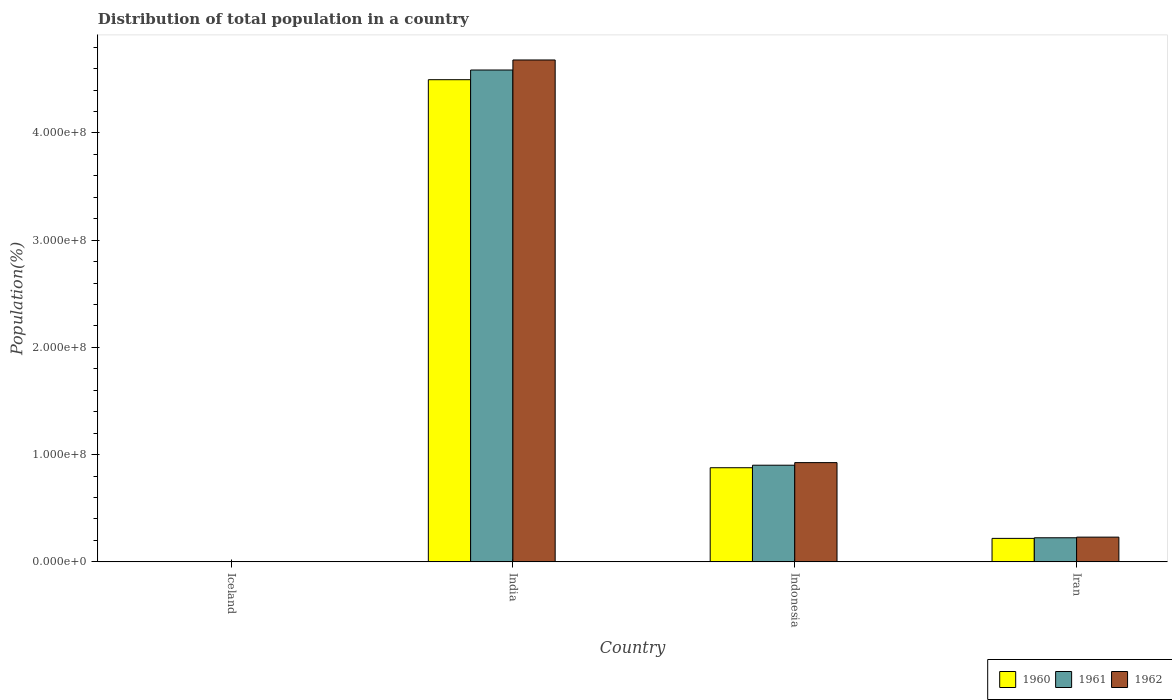Are the number of bars per tick equal to the number of legend labels?
Provide a succinct answer. Yes. What is the label of the 1st group of bars from the left?
Give a very brief answer. Iceland. What is the population of in 1960 in Iran?
Offer a terse response. 2.19e+07. Across all countries, what is the maximum population of in 1960?
Provide a short and direct response. 4.50e+08. Across all countries, what is the minimum population of in 1961?
Give a very brief answer. 1.79e+05. In which country was the population of in 1962 maximum?
Your answer should be very brief. India. What is the total population of in 1960 in the graph?
Provide a succinct answer. 5.60e+08. What is the difference between the population of in 1961 in Indonesia and that in Iran?
Keep it short and to the point. 6.77e+07. What is the difference between the population of in 1960 in Iran and the population of in 1961 in Iceland?
Offer a terse response. 2.17e+07. What is the average population of in 1961 per country?
Provide a short and direct response. 1.43e+08. What is the difference between the population of of/in 1962 and population of of/in 1961 in India?
Your response must be concise. 9.36e+06. In how many countries, is the population of in 1962 greater than 420000000 %?
Your response must be concise. 1. What is the ratio of the population of in 1961 in India to that in Indonesia?
Give a very brief answer. 5.09. Is the population of in 1962 in Iceland less than that in Indonesia?
Give a very brief answer. Yes. Is the difference between the population of in 1962 in Indonesia and Iran greater than the difference between the population of in 1961 in Indonesia and Iran?
Ensure brevity in your answer.  Yes. What is the difference between the highest and the second highest population of in 1961?
Make the answer very short. 3.69e+08. What is the difference between the highest and the lowest population of in 1960?
Provide a short and direct response. 4.49e+08. In how many countries, is the population of in 1961 greater than the average population of in 1961 taken over all countries?
Ensure brevity in your answer.  1. Is the sum of the population of in 1960 in Iceland and India greater than the maximum population of in 1961 across all countries?
Offer a terse response. No. What does the 3rd bar from the right in Indonesia represents?
Offer a terse response. 1960. How many bars are there?
Your response must be concise. 12. Are the values on the major ticks of Y-axis written in scientific E-notation?
Offer a terse response. Yes. Does the graph contain any zero values?
Provide a short and direct response. No. Where does the legend appear in the graph?
Your response must be concise. Bottom right. What is the title of the graph?
Provide a succinct answer. Distribution of total population in a country. What is the label or title of the X-axis?
Your answer should be very brief. Country. What is the label or title of the Y-axis?
Make the answer very short. Population(%). What is the Population(%) of 1960 in Iceland?
Give a very brief answer. 1.76e+05. What is the Population(%) in 1961 in Iceland?
Make the answer very short. 1.79e+05. What is the Population(%) in 1962 in Iceland?
Give a very brief answer. 1.82e+05. What is the Population(%) in 1960 in India?
Provide a succinct answer. 4.50e+08. What is the Population(%) of 1961 in India?
Offer a terse response. 4.59e+08. What is the Population(%) of 1962 in India?
Offer a very short reply. 4.68e+08. What is the Population(%) of 1960 in Indonesia?
Ensure brevity in your answer.  8.78e+07. What is the Population(%) of 1961 in Indonesia?
Provide a succinct answer. 9.01e+07. What is the Population(%) of 1962 in Indonesia?
Your answer should be very brief. 9.26e+07. What is the Population(%) of 1960 in Iran?
Give a very brief answer. 2.19e+07. What is the Population(%) of 1961 in Iran?
Your answer should be very brief. 2.25e+07. What is the Population(%) of 1962 in Iran?
Make the answer very short. 2.31e+07. Across all countries, what is the maximum Population(%) of 1960?
Make the answer very short. 4.50e+08. Across all countries, what is the maximum Population(%) in 1961?
Keep it short and to the point. 4.59e+08. Across all countries, what is the maximum Population(%) of 1962?
Offer a terse response. 4.68e+08. Across all countries, what is the minimum Population(%) in 1960?
Your answer should be compact. 1.76e+05. Across all countries, what is the minimum Population(%) in 1961?
Give a very brief answer. 1.79e+05. Across all countries, what is the minimum Population(%) in 1962?
Make the answer very short. 1.82e+05. What is the total Population(%) in 1960 in the graph?
Offer a terse response. 5.60e+08. What is the total Population(%) in 1961 in the graph?
Your answer should be compact. 5.71e+08. What is the total Population(%) in 1962 in the graph?
Provide a succinct answer. 5.84e+08. What is the difference between the Population(%) in 1960 in Iceland and that in India?
Your response must be concise. -4.49e+08. What is the difference between the Population(%) in 1961 in Iceland and that in India?
Give a very brief answer. -4.59e+08. What is the difference between the Population(%) in 1962 in Iceland and that in India?
Provide a short and direct response. -4.68e+08. What is the difference between the Population(%) in 1960 in Iceland and that in Indonesia?
Ensure brevity in your answer.  -8.76e+07. What is the difference between the Population(%) in 1961 in Iceland and that in Indonesia?
Ensure brevity in your answer.  -9.00e+07. What is the difference between the Population(%) in 1962 in Iceland and that in Indonesia?
Provide a short and direct response. -9.24e+07. What is the difference between the Population(%) of 1960 in Iceland and that in Iran?
Your answer should be compact. -2.17e+07. What is the difference between the Population(%) in 1961 in Iceland and that in Iran?
Keep it short and to the point. -2.23e+07. What is the difference between the Population(%) of 1962 in Iceland and that in Iran?
Provide a short and direct response. -2.29e+07. What is the difference between the Population(%) of 1960 in India and that in Indonesia?
Give a very brief answer. 3.62e+08. What is the difference between the Population(%) of 1961 in India and that in Indonesia?
Ensure brevity in your answer.  3.69e+08. What is the difference between the Population(%) of 1962 in India and that in Indonesia?
Keep it short and to the point. 3.75e+08. What is the difference between the Population(%) of 1960 in India and that in Iran?
Offer a very short reply. 4.28e+08. What is the difference between the Population(%) of 1961 in India and that in Iran?
Your answer should be compact. 4.36e+08. What is the difference between the Population(%) in 1962 in India and that in Iran?
Your answer should be very brief. 4.45e+08. What is the difference between the Population(%) of 1960 in Indonesia and that in Iran?
Give a very brief answer. 6.59e+07. What is the difference between the Population(%) of 1961 in Indonesia and that in Iran?
Provide a succinct answer. 6.77e+07. What is the difference between the Population(%) of 1962 in Indonesia and that in Iran?
Keep it short and to the point. 6.95e+07. What is the difference between the Population(%) of 1960 in Iceland and the Population(%) of 1961 in India?
Your response must be concise. -4.59e+08. What is the difference between the Population(%) of 1960 in Iceland and the Population(%) of 1962 in India?
Keep it short and to the point. -4.68e+08. What is the difference between the Population(%) in 1961 in Iceland and the Population(%) in 1962 in India?
Give a very brief answer. -4.68e+08. What is the difference between the Population(%) in 1960 in Iceland and the Population(%) in 1961 in Indonesia?
Offer a terse response. -9.00e+07. What is the difference between the Population(%) of 1960 in Iceland and the Population(%) of 1962 in Indonesia?
Provide a short and direct response. -9.24e+07. What is the difference between the Population(%) in 1961 in Iceland and the Population(%) in 1962 in Indonesia?
Your response must be concise. -9.24e+07. What is the difference between the Population(%) of 1960 in Iceland and the Population(%) of 1961 in Iran?
Make the answer very short. -2.23e+07. What is the difference between the Population(%) of 1960 in Iceland and the Population(%) of 1962 in Iran?
Make the answer very short. -2.29e+07. What is the difference between the Population(%) of 1961 in Iceland and the Population(%) of 1962 in Iran?
Give a very brief answer. -2.29e+07. What is the difference between the Population(%) in 1960 in India and the Population(%) in 1961 in Indonesia?
Your response must be concise. 3.60e+08. What is the difference between the Population(%) of 1960 in India and the Population(%) of 1962 in Indonesia?
Make the answer very short. 3.57e+08. What is the difference between the Population(%) in 1961 in India and the Population(%) in 1962 in Indonesia?
Ensure brevity in your answer.  3.66e+08. What is the difference between the Population(%) in 1960 in India and the Population(%) in 1961 in Iran?
Provide a succinct answer. 4.27e+08. What is the difference between the Population(%) in 1960 in India and the Population(%) in 1962 in Iran?
Offer a very short reply. 4.27e+08. What is the difference between the Population(%) of 1961 in India and the Population(%) of 1962 in Iran?
Ensure brevity in your answer.  4.36e+08. What is the difference between the Population(%) of 1960 in Indonesia and the Population(%) of 1961 in Iran?
Offer a very short reply. 6.53e+07. What is the difference between the Population(%) of 1960 in Indonesia and the Population(%) of 1962 in Iran?
Offer a very short reply. 6.47e+07. What is the difference between the Population(%) in 1961 in Indonesia and the Population(%) in 1962 in Iran?
Make the answer very short. 6.71e+07. What is the average Population(%) of 1960 per country?
Provide a succinct answer. 1.40e+08. What is the average Population(%) of 1961 per country?
Offer a terse response. 1.43e+08. What is the average Population(%) in 1962 per country?
Provide a succinct answer. 1.46e+08. What is the difference between the Population(%) in 1960 and Population(%) in 1961 in Iceland?
Give a very brief answer. -3455. What is the difference between the Population(%) of 1960 and Population(%) of 1962 in Iceland?
Provide a succinct answer. -6804. What is the difference between the Population(%) of 1961 and Population(%) of 1962 in Iceland?
Keep it short and to the point. -3349. What is the difference between the Population(%) in 1960 and Population(%) in 1961 in India?
Provide a short and direct response. -9.03e+06. What is the difference between the Population(%) of 1960 and Population(%) of 1962 in India?
Your answer should be compact. -1.84e+07. What is the difference between the Population(%) of 1961 and Population(%) of 1962 in India?
Make the answer very short. -9.36e+06. What is the difference between the Population(%) of 1960 and Population(%) of 1961 in Indonesia?
Keep it short and to the point. -2.35e+06. What is the difference between the Population(%) of 1960 and Population(%) of 1962 in Indonesia?
Ensure brevity in your answer.  -4.77e+06. What is the difference between the Population(%) of 1961 and Population(%) of 1962 in Indonesia?
Give a very brief answer. -2.42e+06. What is the difference between the Population(%) of 1960 and Population(%) of 1961 in Iran?
Your response must be concise. -5.74e+05. What is the difference between the Population(%) of 1960 and Population(%) of 1962 in Iran?
Provide a short and direct response. -1.16e+06. What is the difference between the Population(%) in 1961 and Population(%) in 1962 in Iran?
Make the answer very short. -5.91e+05. What is the ratio of the Population(%) of 1960 in Iceland to that in India?
Ensure brevity in your answer.  0. What is the ratio of the Population(%) of 1960 in Iceland to that in Indonesia?
Keep it short and to the point. 0. What is the ratio of the Population(%) of 1961 in Iceland to that in Indonesia?
Your response must be concise. 0. What is the ratio of the Population(%) of 1962 in Iceland to that in Indonesia?
Keep it short and to the point. 0. What is the ratio of the Population(%) in 1960 in Iceland to that in Iran?
Keep it short and to the point. 0.01. What is the ratio of the Population(%) in 1961 in Iceland to that in Iran?
Provide a succinct answer. 0.01. What is the ratio of the Population(%) in 1962 in Iceland to that in Iran?
Your answer should be very brief. 0.01. What is the ratio of the Population(%) in 1960 in India to that in Indonesia?
Provide a short and direct response. 5.12. What is the ratio of the Population(%) in 1961 in India to that in Indonesia?
Your answer should be compact. 5.09. What is the ratio of the Population(%) of 1962 in India to that in Indonesia?
Your response must be concise. 5.06. What is the ratio of the Population(%) in 1960 in India to that in Iran?
Your answer should be compact. 20.53. What is the ratio of the Population(%) of 1961 in India to that in Iran?
Offer a terse response. 20.4. What is the ratio of the Population(%) in 1962 in India to that in Iran?
Keep it short and to the point. 20.29. What is the ratio of the Population(%) in 1960 in Indonesia to that in Iran?
Offer a very short reply. 4.01. What is the ratio of the Population(%) of 1961 in Indonesia to that in Iran?
Ensure brevity in your answer.  4.01. What is the ratio of the Population(%) of 1962 in Indonesia to that in Iran?
Provide a short and direct response. 4.01. What is the difference between the highest and the second highest Population(%) of 1960?
Your answer should be compact. 3.62e+08. What is the difference between the highest and the second highest Population(%) of 1961?
Offer a very short reply. 3.69e+08. What is the difference between the highest and the second highest Population(%) of 1962?
Your answer should be compact. 3.75e+08. What is the difference between the highest and the lowest Population(%) in 1960?
Provide a succinct answer. 4.49e+08. What is the difference between the highest and the lowest Population(%) in 1961?
Your response must be concise. 4.59e+08. What is the difference between the highest and the lowest Population(%) in 1962?
Offer a very short reply. 4.68e+08. 